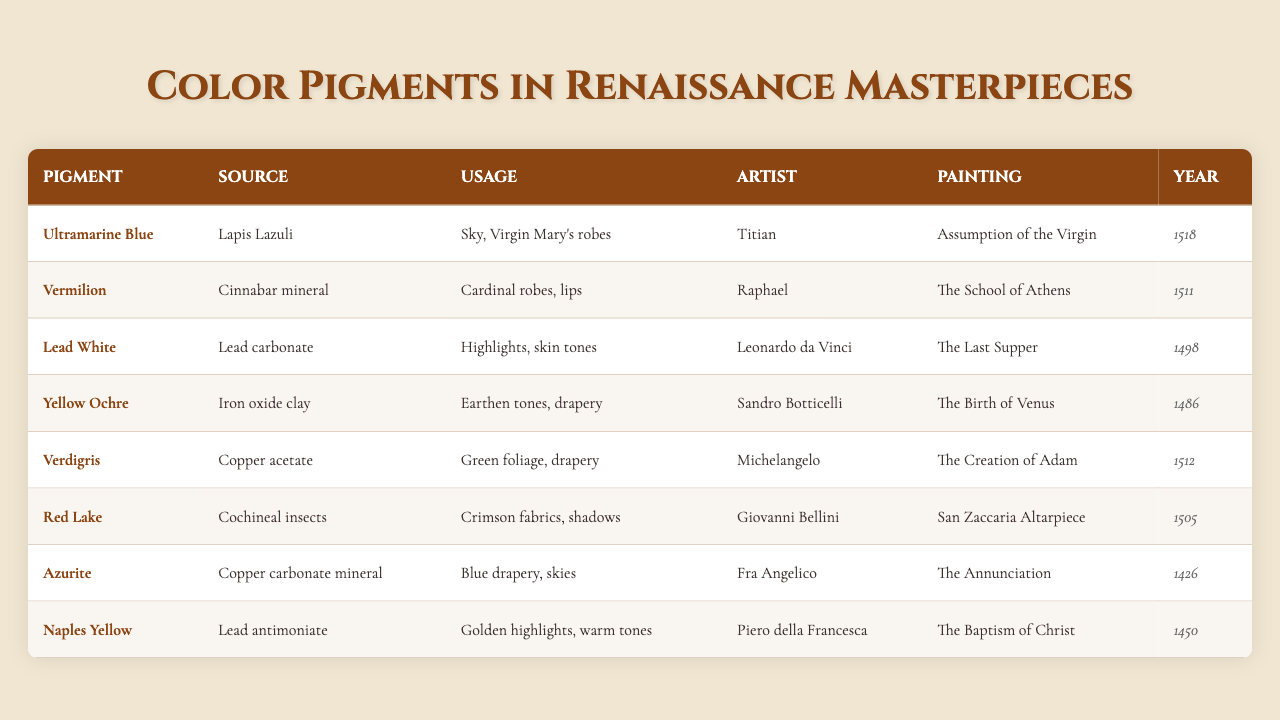What year was "The Birth of Venus" painted? The table lists "The Birth of Venus" under the painting column, and the corresponding year is 1486.
Answer: 1486 Who used Vermilion in their artwork? Looking at the artist column, Vermilion is associated with Raphael, who used it in "The School of Athens."
Answer: Raphael What was the source of the pigment Lead White? The table indicates that Lead White comes from Lead carbonate.
Answer: Lead carbonate Was Ultramarine Blue used in any paintings before the year 1500? By examining the year column, Ultramarine Blue was used in "Assumption of the Virgin," which was painted in 1518, after 1500. Therefore, the answer is no.
Answer: No Which artist used Verdigris, and for what purpose? The table states that Michelangelo used Verdigris for green foliage and drapery in "The Creation of Adam."
Answer: Michelangelo; green foliage and drapery Which pigment was used in Cardinal robes? The usage column shows that Vermilion was used for Cardinal robes; it is associated with Raphael's "The School of Athens."
Answer: Vermilion How many pigments listed in the table were used by artists in the 1500s? The years listed for the pigments include 1518, 1511, and 1512 which corresponds to a total of 3 pigments used in the 1500s.
Answer: 3 Which pigment has the source of Copper acetate? Verdigris is the pigment that has Copper acetate as its source according to the table.
Answer: Verdigris What is the primary color associated with Azurite? The table indicates that Azurite was used for blue drapery and skies.
Answer: Blue Did any artists listed use multiple pigments in their works? Specifically referring to the table, there’s no indication that any artist is listed using more than one pigment in their works shown here. So the answer is no.
Answer: No What is the average year of the paintings listed in the table? To find the average year: (1518 + 1511 + 1498 + 1486 + 1512 + 1505 + 1426 + 1450) / 8 = 1497.75, rounded down, this gives us the average year 1498.
Answer: 1498 